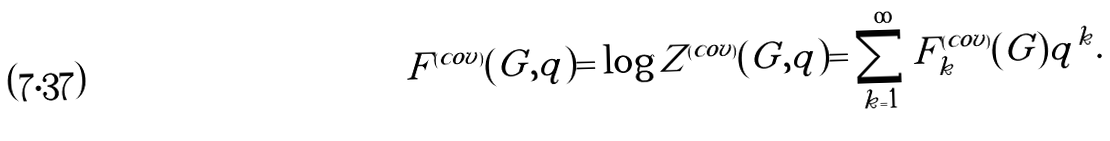Convert formula to latex. <formula><loc_0><loc_0><loc_500><loc_500>F ^ { ( c o v ) } ( G , q ) = \log Z ^ { ( c o v ) } ( G , q ) = \sum _ { k = 1 } ^ { \infty } F _ { k } ^ { ( c o v ) } ( G ) q ^ { k } .</formula> 